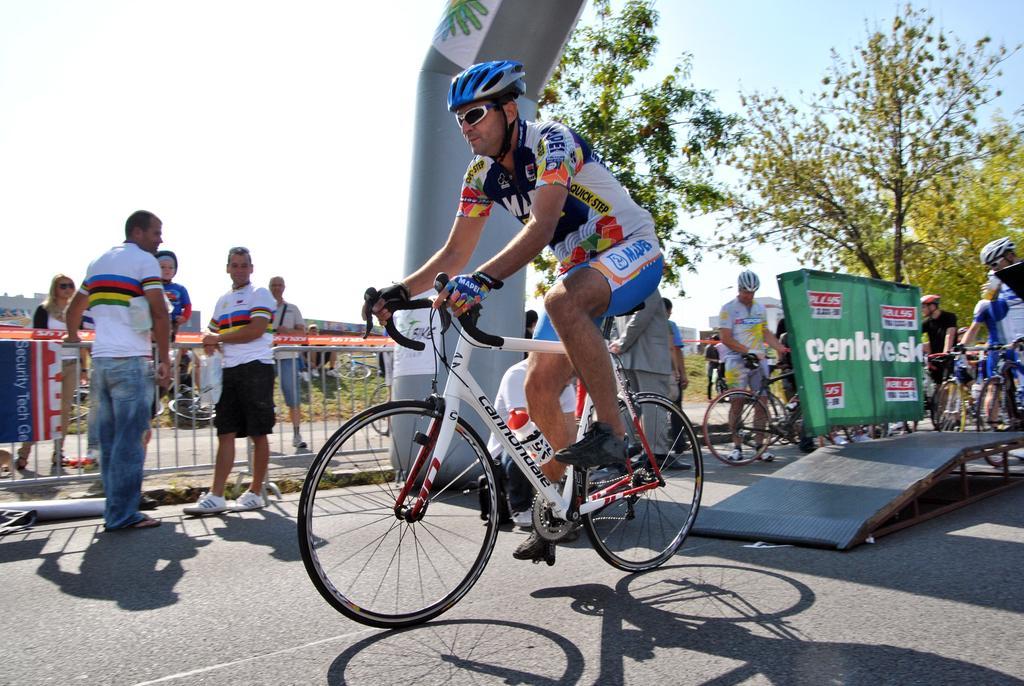Could you give a brief overview of what you see in this image? This is a picture taken in the outdoors. It is sunny. The man in white t shirt is wearing a helmet and riding his bicycle on the road and group of people are also riding their bicycles. Behind the people there are group of people standing on a path, trees and sky. 